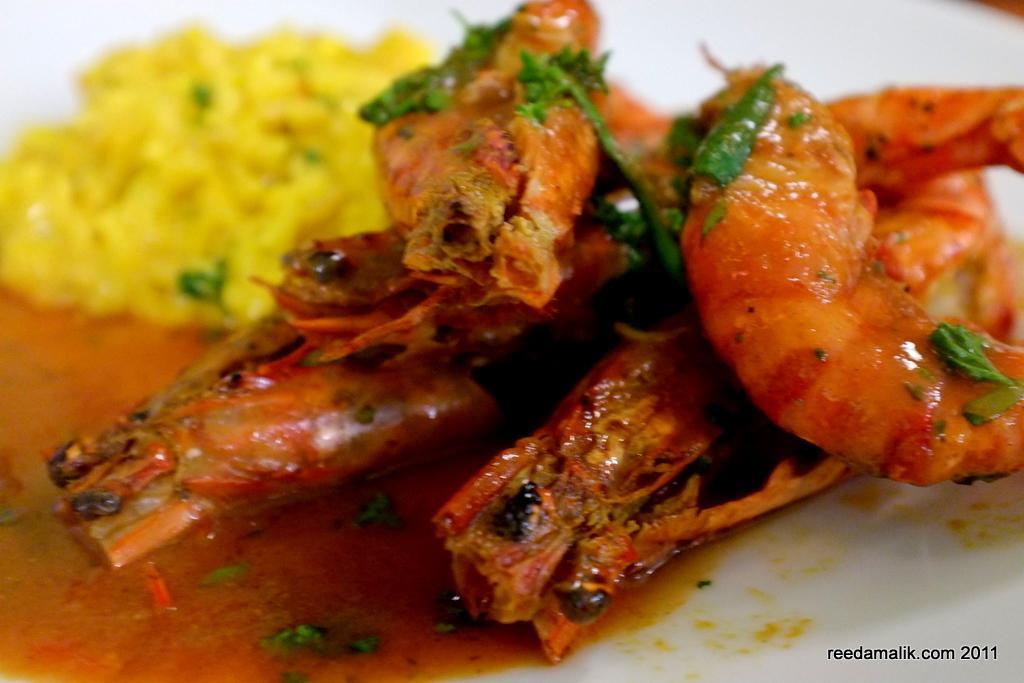Describe this image in one or two sentences. In the center of the image we can see one plate. In the plate, we can see some food items. At the bottom right side of the image, we can see some text. 